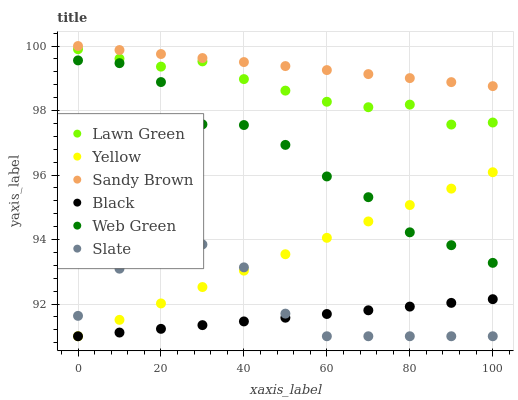Does Black have the minimum area under the curve?
Answer yes or no. Yes. Does Sandy Brown have the maximum area under the curve?
Answer yes or no. Yes. Does Slate have the minimum area under the curve?
Answer yes or no. No. Does Slate have the maximum area under the curve?
Answer yes or no. No. Is Yellow the smoothest?
Answer yes or no. Yes. Is Web Green the roughest?
Answer yes or no. Yes. Is Slate the smoothest?
Answer yes or no. No. Is Slate the roughest?
Answer yes or no. No. Does Slate have the lowest value?
Answer yes or no. Yes. Does Web Green have the lowest value?
Answer yes or no. No. Does Sandy Brown have the highest value?
Answer yes or no. Yes. Does Slate have the highest value?
Answer yes or no. No. Is Black less than Sandy Brown?
Answer yes or no. Yes. Is Sandy Brown greater than Yellow?
Answer yes or no. Yes. Does Black intersect Yellow?
Answer yes or no. Yes. Is Black less than Yellow?
Answer yes or no. No. Is Black greater than Yellow?
Answer yes or no. No. Does Black intersect Sandy Brown?
Answer yes or no. No. 